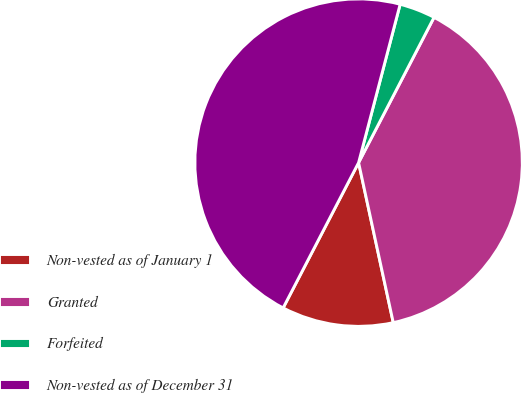Convert chart to OTSL. <chart><loc_0><loc_0><loc_500><loc_500><pie_chart><fcel>Non-vested as of January 1<fcel>Granted<fcel>Forfeited<fcel>Non-vested as of December 31<nl><fcel>11.02%<fcel>38.98%<fcel>3.54%<fcel>46.46%<nl></chart> 